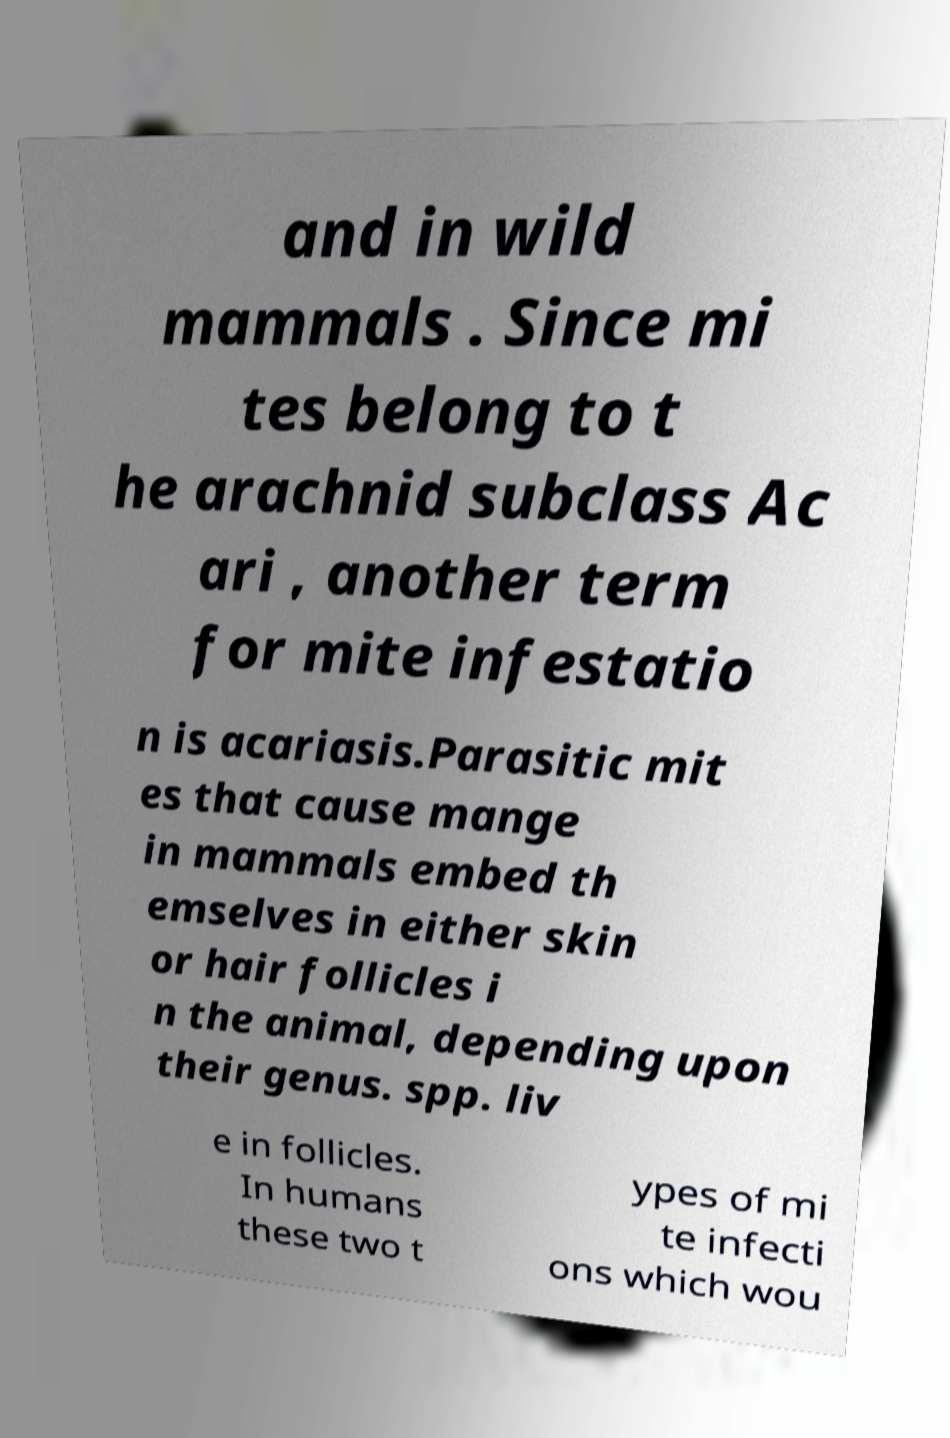Could you extract and type out the text from this image? and in wild mammals . Since mi tes belong to t he arachnid subclass Ac ari , another term for mite infestatio n is acariasis.Parasitic mit es that cause mange in mammals embed th emselves in either skin or hair follicles i n the animal, depending upon their genus. spp. liv e in follicles. In humans these two t ypes of mi te infecti ons which wou 